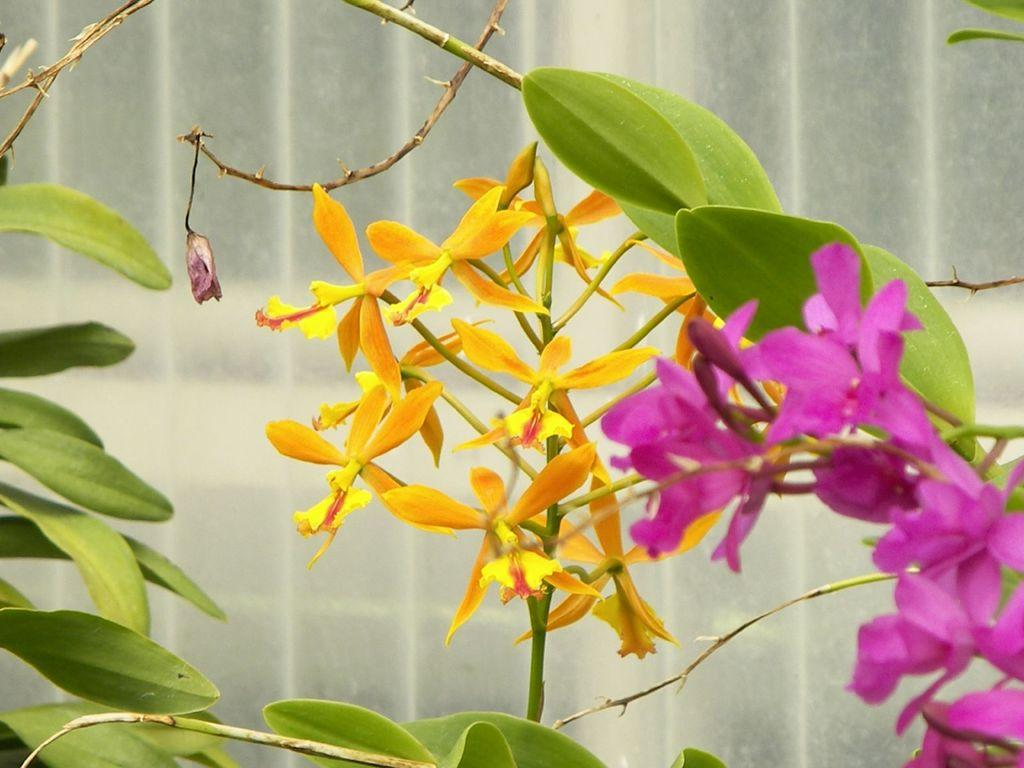What type of vegetation is visible in the front of the image? There are leaves in the front of the image. What other natural elements can be seen in the image? There are flowers in the image. Can you describe the background of the image? The background of the image is blurry. What type of bear can be seen playing a game in the background of the image? There is no bear or game present in the image; it features leaves, flowers, and a blurry background. 